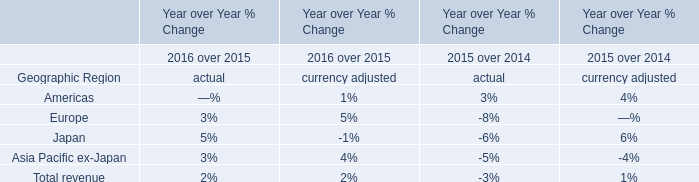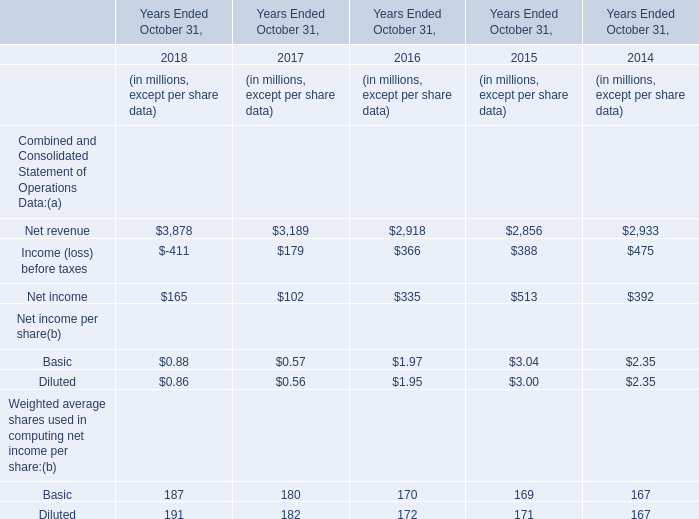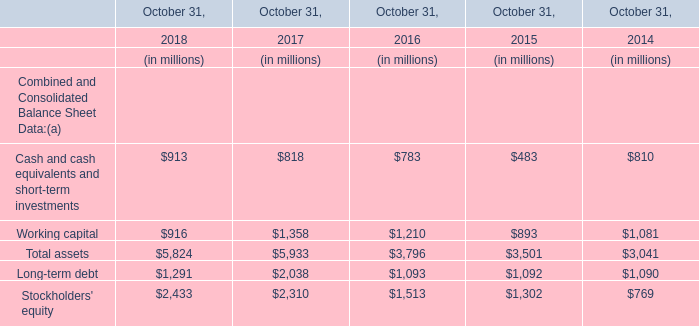What will Net revenue reach in 2019 if it continues to grow at its current rate? (in million) 
Computations: (3878 * (1 + ((3878 - 3189) / 3189)))
Answer: 4715.86203. 